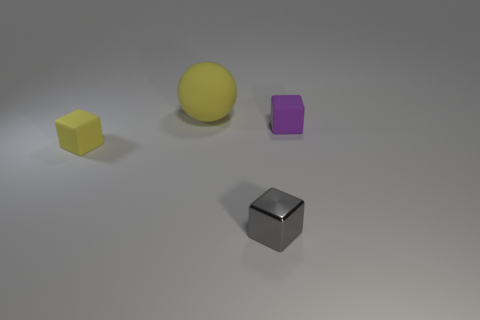There is a yellow thing that is in front of the purple matte thing; how big is it?
Your answer should be compact. Small. Are there any tiny cubes that have the same color as the ball?
Your answer should be very brief. Yes. Does the matte cube on the right side of the gray metal cube have the same size as the big yellow ball?
Offer a terse response. No. Is there anything else that is the same size as the yellow rubber sphere?
Your response must be concise. No. How many other things are the same color as the big thing?
Make the answer very short. 1. Are the ball and the small object behind the small yellow block made of the same material?
Offer a terse response. Yes. There is a tiny rubber object that is on the right side of the yellow object to the left of the sphere; what number of small blocks are on the left side of it?
Keep it short and to the point. 2. Is the number of tiny cubes in front of the gray metallic thing less than the number of big matte things to the right of the big matte ball?
Ensure brevity in your answer.  No. What number of other things are made of the same material as the gray cube?
Your response must be concise. 0. What material is the purple block that is the same size as the gray object?
Your response must be concise. Rubber. 